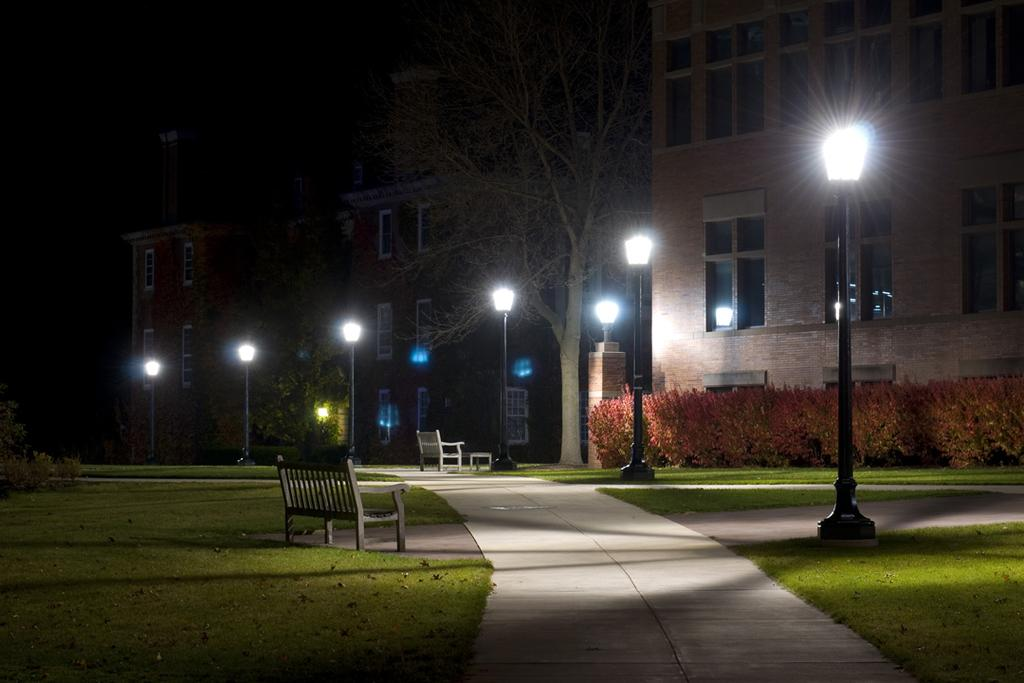What type of lighting can be seen in the image? There are street lights in the image. What type of seating is available in the image? There are benches in the image. What type of vegetation is present in the image? There are plants, grass, and trees in the image. What type of structures can be seen in the image? There are buildings in the image. What part of the natural environment is visible in the image? The sky is visible in the image. What type of office can be seen in the image? There is no office present in the image. How much has the growth of the plants in the image increased since last year? The image does not provide information about the growth of the plants over time. 